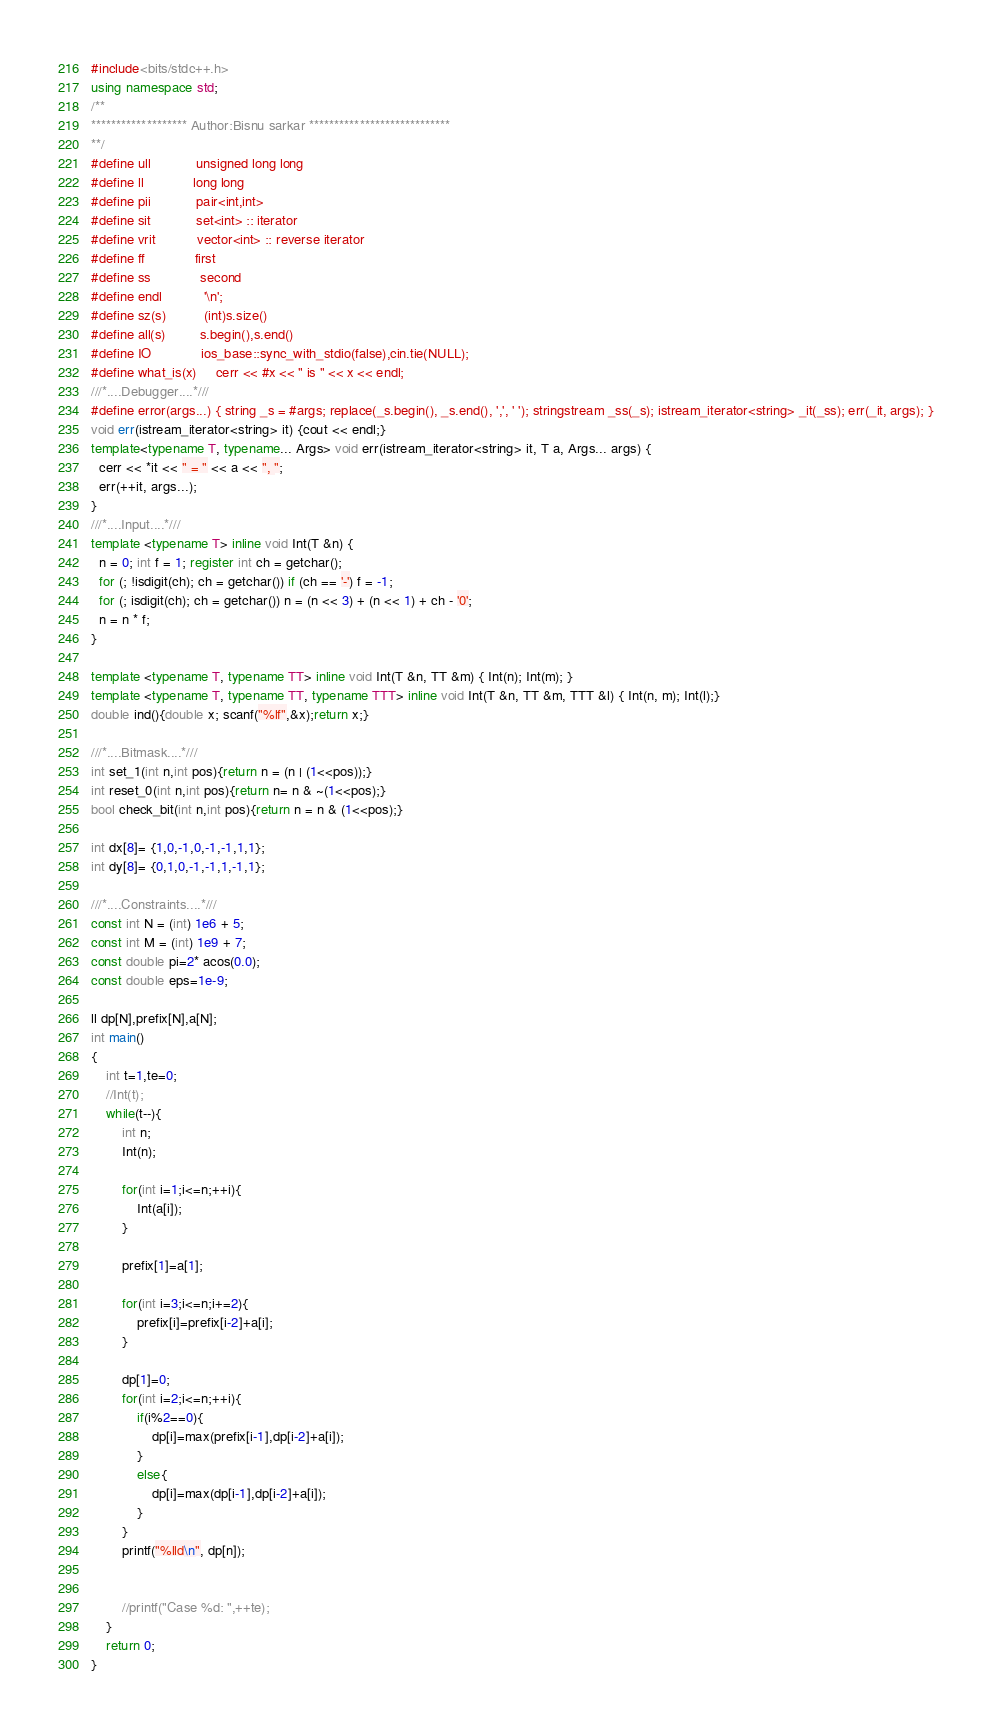Convert code to text. <code><loc_0><loc_0><loc_500><loc_500><_C++_>
#include<bits/stdc++.h>
using namespace std;
/**
******************* Author:Bisnu sarkar ****************************
**/
#define ull            unsigned long long
#define ll             long long
#define pii            pair<int,int>
#define sit            set<int> :: iterator
#define vrit           vector<int> :: reverse iterator
#define ff             first
#define ss             second
#define endl           '\n';
#define sz(s)          (int)s.size()
#define all(s)         s.begin(),s.end()
#define IO             ios_base::sync_with_stdio(false),cin.tie(NULL);  
#define what_is(x)     cerr << #x << " is " << x << endl;
///*....Debugger....*///
#define error(args...) { string _s = #args; replace(_s.begin(), _s.end(), ',', ' '); stringstream _ss(_s); istream_iterator<string> _it(_ss); err(_it, args); }
void err(istream_iterator<string> it) {cout << endl;}
template<typename T, typename... Args> void err(istream_iterator<string> it, T a, Args... args) {
  cerr << *it << " = " << a << ", ";
  err(++it, args...);
}
///*....Input....*///
template <typename T> inline void Int(T &n) {
  n = 0; int f = 1; register int ch = getchar();
  for (; !isdigit(ch); ch = getchar()) if (ch == '-') f = -1;
  for (; isdigit(ch); ch = getchar()) n = (n << 3) + (n << 1) + ch - '0';
  n = n * f;
}
 
template <typename T, typename TT> inline void Int(T &n, TT &m) { Int(n); Int(m); }
template <typename T, typename TT, typename TTT> inline void Int(T &n, TT &m, TTT &l) { Int(n, m); Int(l);}
double ind(){double x; scanf("%lf",&x);return x;}

///*....Bitmask....*///
int set_1(int n,int pos){return n = (n | (1<<pos));}
int reset_0(int n,int pos){return n= n & ~(1<<pos);}
bool check_bit(int n,int pos){return n = n & (1<<pos);}

int dx[8]= {1,0,-1,0,-1,-1,1,1};
int dy[8]= {0,1,0,-1,-1,1,-1,1};

///*....Constraints....*///
const int N = (int) 1e6 + 5;
const int M = (int) 1e9 + 7;
const double pi=2* acos(0.0);
const double eps=1e-9;

ll dp[N],prefix[N],a[N];
int main()
{
    int t=1,te=0;
    //Int(t);
    while(t--){
		int n;
		Int(n);

		for(int i=1;i<=n;++i){
			Int(a[i]);
		}  

		prefix[1]=a[1];

		for(int i=3;i<=n;i+=2){
			prefix[i]=prefix[i-2]+a[i];
		}

		dp[1]=0;
		for(int i=2;i<=n;++i){
			if(i%2==0){
				dp[i]=max(prefix[i-1],dp[i-2]+a[i]);
			}
			else{
				dp[i]=max(dp[i-1],dp[i-2]+a[i]);
			}
		}
		printf("%lld\n", dp[n]);


        //printf("Case %d: ",++te);
    }
    return 0;
}

</code> 